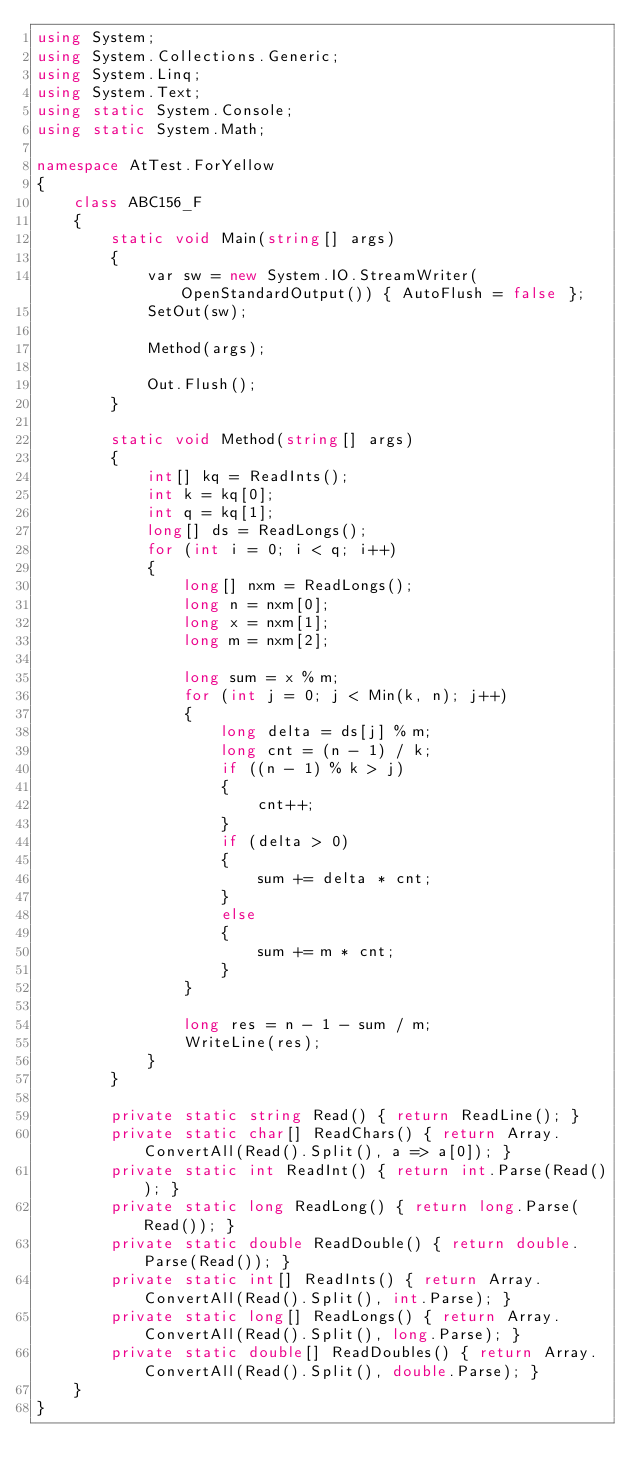<code> <loc_0><loc_0><loc_500><loc_500><_C#_>using System;
using System.Collections.Generic;
using System.Linq;
using System.Text;
using static System.Console;
using static System.Math;

namespace AtTest.ForYellow
{
    class ABC156_F
    {
        static void Main(string[] args)
        {
            var sw = new System.IO.StreamWriter(OpenStandardOutput()) { AutoFlush = false };
            SetOut(sw);

            Method(args);

            Out.Flush();
        }

        static void Method(string[] args)
        {
            int[] kq = ReadInts();
            int k = kq[0];
            int q = kq[1];
            long[] ds = ReadLongs();
            for (int i = 0; i < q; i++)
            {
                long[] nxm = ReadLongs();
                long n = nxm[0];
                long x = nxm[1];
                long m = nxm[2];

                long sum = x % m;
                for (int j = 0; j < Min(k, n); j++)
                {
                    long delta = ds[j] % m;
                    long cnt = (n - 1) / k;
                    if ((n - 1) % k > j)
                    {
                        cnt++;
                    }
                    if (delta > 0)
                    {
                        sum += delta * cnt;
                    }
                    else
                    {
                        sum += m * cnt;
                    }
                }

                long res = n - 1 - sum / m;
                WriteLine(res);
            }
        }

        private static string Read() { return ReadLine(); }
        private static char[] ReadChars() { return Array.ConvertAll(Read().Split(), a => a[0]); }
        private static int ReadInt() { return int.Parse(Read()); }
        private static long ReadLong() { return long.Parse(Read()); }
        private static double ReadDouble() { return double.Parse(Read()); }
        private static int[] ReadInts() { return Array.ConvertAll(Read().Split(), int.Parse); }
        private static long[] ReadLongs() { return Array.ConvertAll(Read().Split(), long.Parse); }
        private static double[] ReadDoubles() { return Array.ConvertAll(Read().Split(), double.Parse); }
    }
}
</code> 